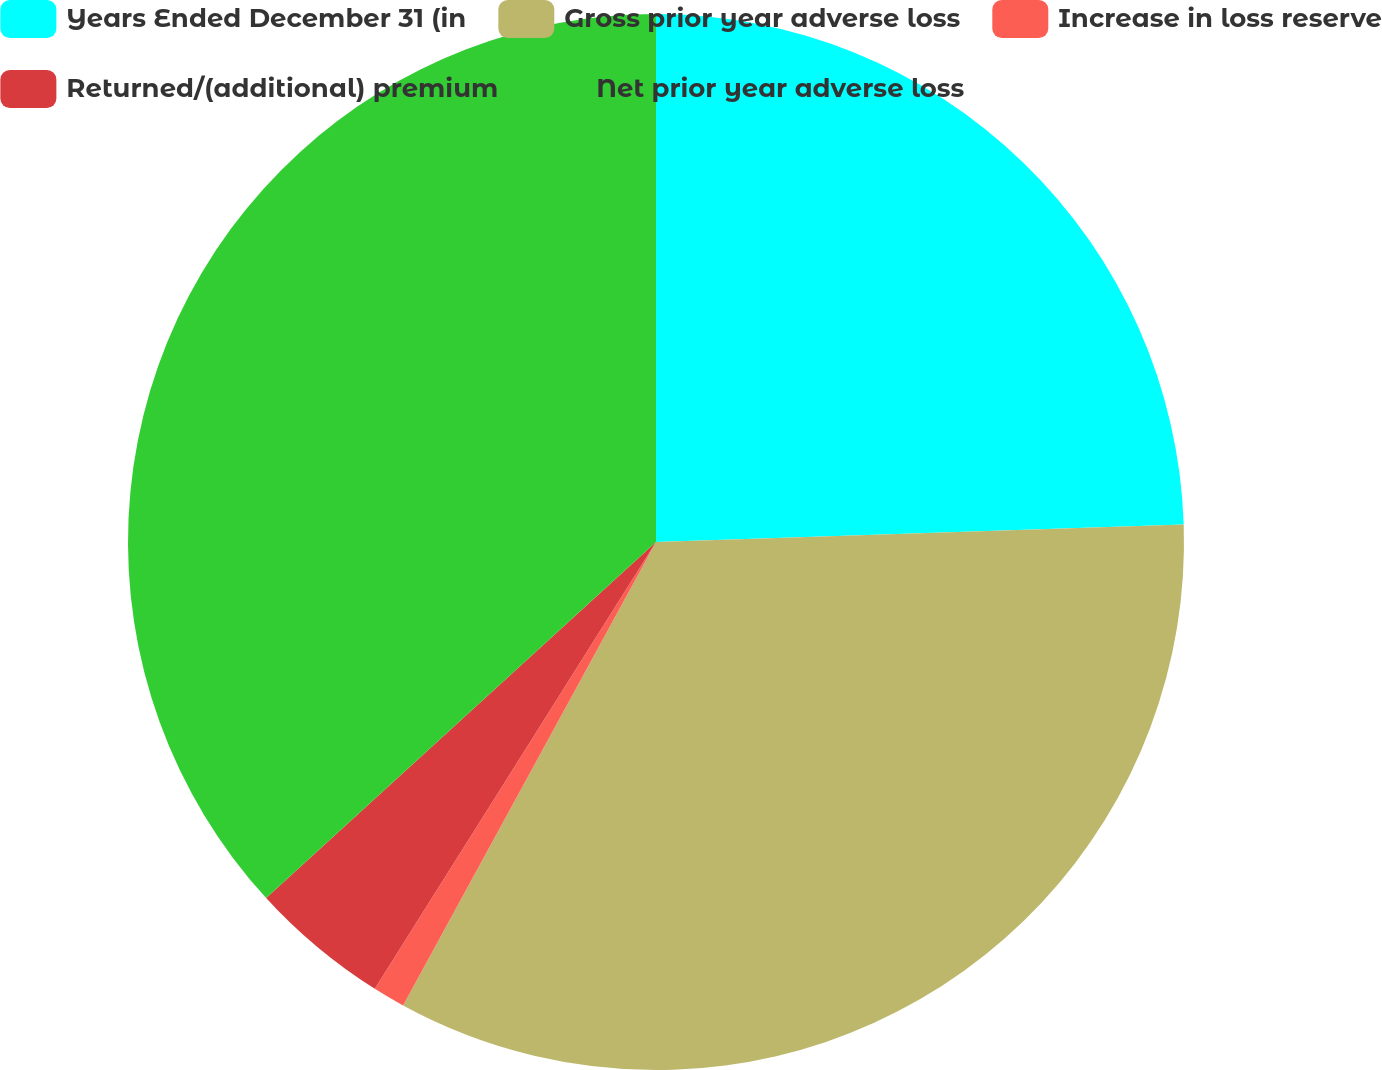Convert chart to OTSL. <chart><loc_0><loc_0><loc_500><loc_500><pie_chart><fcel>Years Ended December 31 (in<fcel>Gross prior year adverse loss<fcel>Increase in loss reserve<fcel>Returned/(additional) premium<fcel>Net prior year adverse loss<nl><fcel>24.47%<fcel>33.48%<fcel>0.99%<fcel>4.28%<fcel>36.78%<nl></chart> 